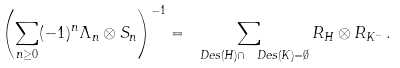Convert formula to latex. <formula><loc_0><loc_0><loc_500><loc_500>\left ( \sum _ { n \geq 0 } ( - 1 ) ^ { n } \Lambda _ { n } \otimes S _ { n } \right ) ^ { - 1 } = \sum _ { \ D e s ( H ) \cap \ D e s ( K ) = \emptyset } R _ { H } \otimes R _ { K ^ { \sim } } \, .</formula> 